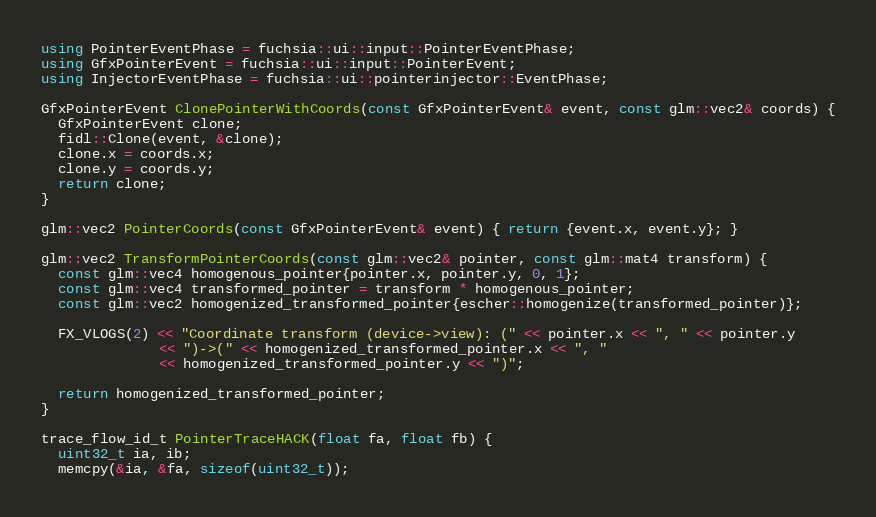Convert code to text. <code><loc_0><loc_0><loc_500><loc_500><_C++_>using PointerEventPhase = fuchsia::ui::input::PointerEventPhase;
using GfxPointerEvent = fuchsia::ui::input::PointerEvent;
using InjectorEventPhase = fuchsia::ui::pointerinjector::EventPhase;

GfxPointerEvent ClonePointerWithCoords(const GfxPointerEvent& event, const glm::vec2& coords) {
  GfxPointerEvent clone;
  fidl::Clone(event, &clone);
  clone.x = coords.x;
  clone.y = coords.y;
  return clone;
}

glm::vec2 PointerCoords(const GfxPointerEvent& event) { return {event.x, event.y}; }

glm::vec2 TransformPointerCoords(const glm::vec2& pointer, const glm::mat4 transform) {
  const glm::vec4 homogenous_pointer{pointer.x, pointer.y, 0, 1};
  const glm::vec4 transformed_pointer = transform * homogenous_pointer;
  const glm::vec2 homogenized_transformed_pointer{escher::homogenize(transformed_pointer)};

  FX_VLOGS(2) << "Coordinate transform (device->view): (" << pointer.x << ", " << pointer.y
              << ")->(" << homogenized_transformed_pointer.x << ", "
              << homogenized_transformed_pointer.y << ")";

  return homogenized_transformed_pointer;
}

trace_flow_id_t PointerTraceHACK(float fa, float fb) {
  uint32_t ia, ib;
  memcpy(&ia, &fa, sizeof(uint32_t));</code> 